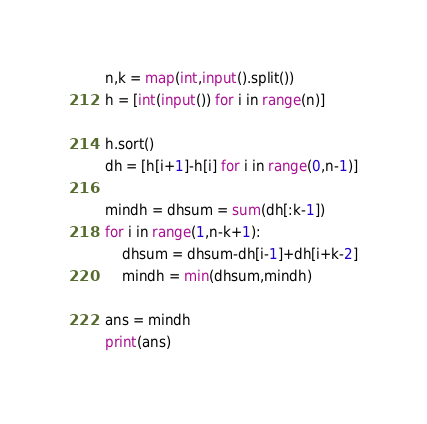Convert code to text. <code><loc_0><loc_0><loc_500><loc_500><_Python_>n,k = map(int,input().split())
h = [int(input()) for i in range(n)]

h.sort()
dh = [h[i+1]-h[i] for i in range(0,n-1)]

mindh = dhsum = sum(dh[:k-1])
for i in range(1,n-k+1):
    dhsum = dhsum-dh[i-1]+dh[i+k-2]
    mindh = min(dhsum,mindh)

ans = mindh
print(ans)</code> 